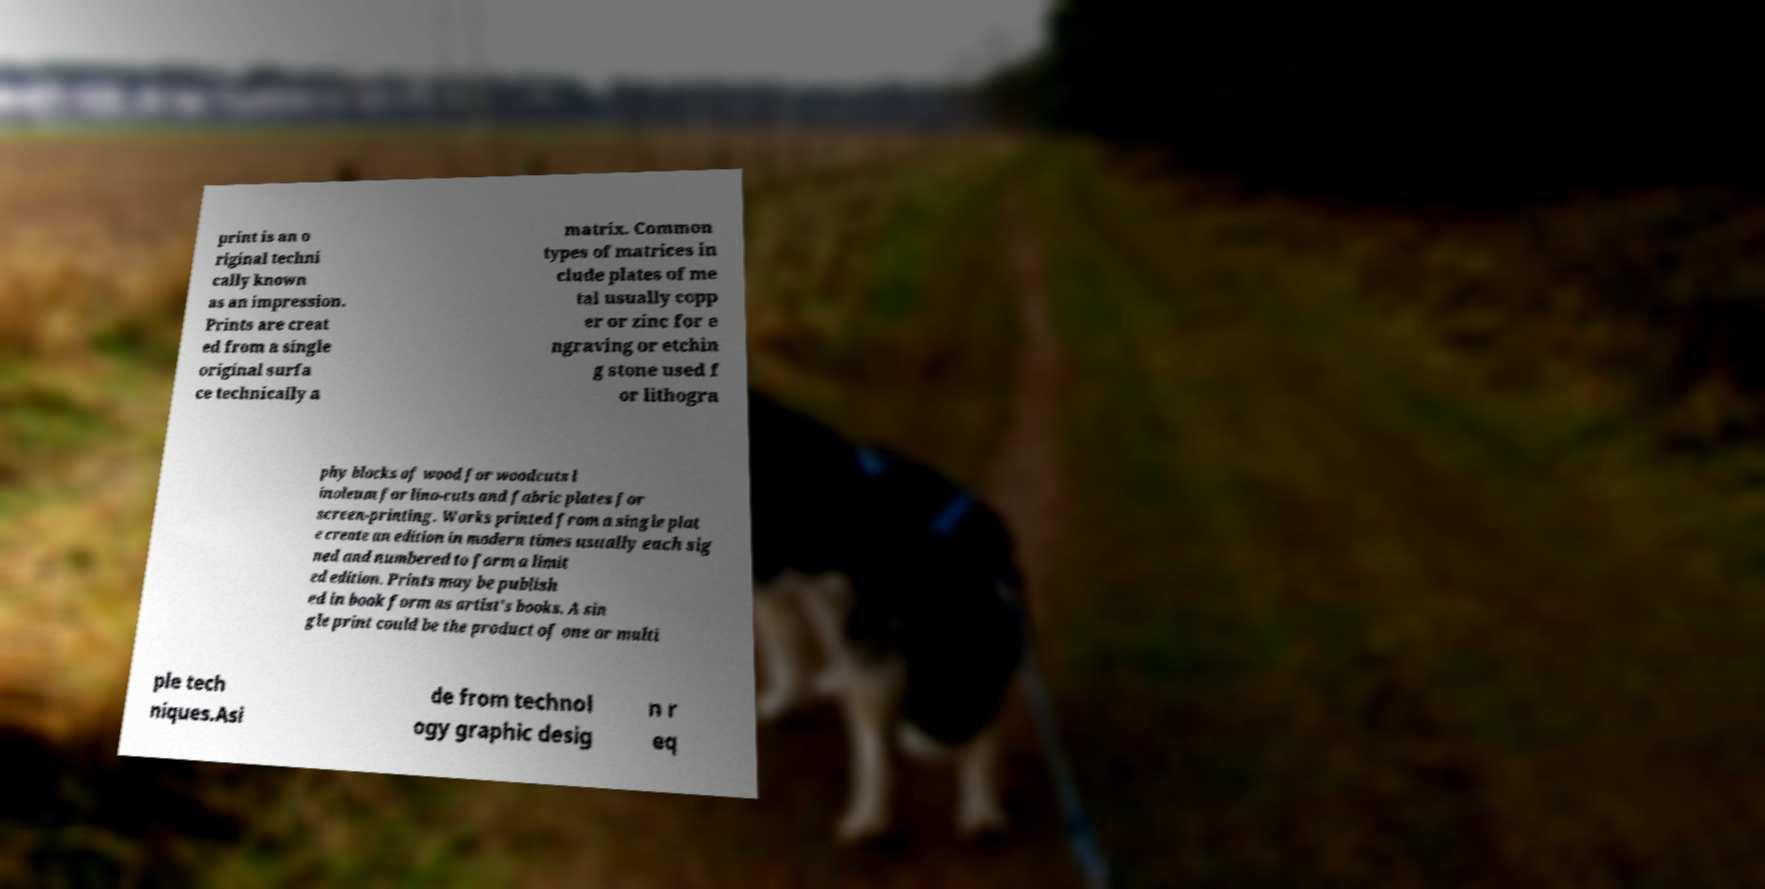What messages or text are displayed in this image? I need them in a readable, typed format. print is an o riginal techni cally known as an impression. Prints are creat ed from a single original surfa ce technically a matrix. Common types of matrices in clude plates of me tal usually copp er or zinc for e ngraving or etchin g stone used f or lithogra phy blocks of wood for woodcuts l inoleum for lino-cuts and fabric plates for screen-printing. Works printed from a single plat e create an edition in modern times usually each sig ned and numbered to form a limit ed edition. Prints may be publish ed in book form as artist's books. A sin gle print could be the product of one or multi ple tech niques.Asi de from technol ogy graphic desig n r eq 